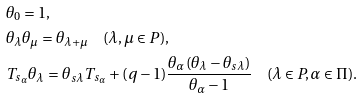Convert formula to latex. <formula><loc_0><loc_0><loc_500><loc_500>& \theta _ { 0 } = 1 , \\ & \theta _ { \lambda } \theta _ { \mu } = \theta _ { \lambda + \mu } \quad ( \lambda , \mu \in P ) , \\ & T _ { s _ { \alpha } } \theta _ { \lambda } = \theta _ { s \lambda } T _ { s _ { \alpha } } + ( q - 1 ) \frac { \theta _ { \alpha } ( \theta _ { \lambda } - \theta _ { s \lambda } ) } { \theta _ { \alpha } - 1 } \quad ( \lambda \in P , \alpha \in \Pi ) .</formula> 